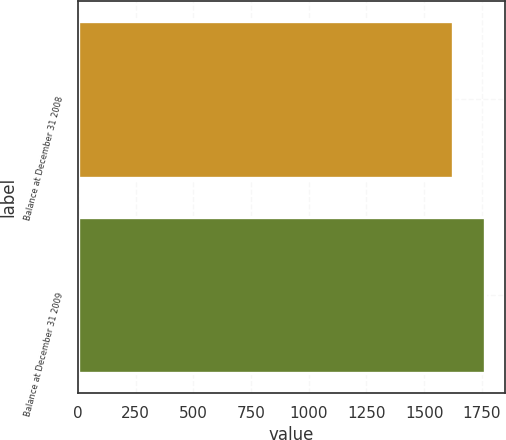Convert chart to OTSL. <chart><loc_0><loc_0><loc_500><loc_500><bar_chart><fcel>Balance at December 31 2008<fcel>Balance at December 31 2009<nl><fcel>1625<fcel>1763<nl></chart> 